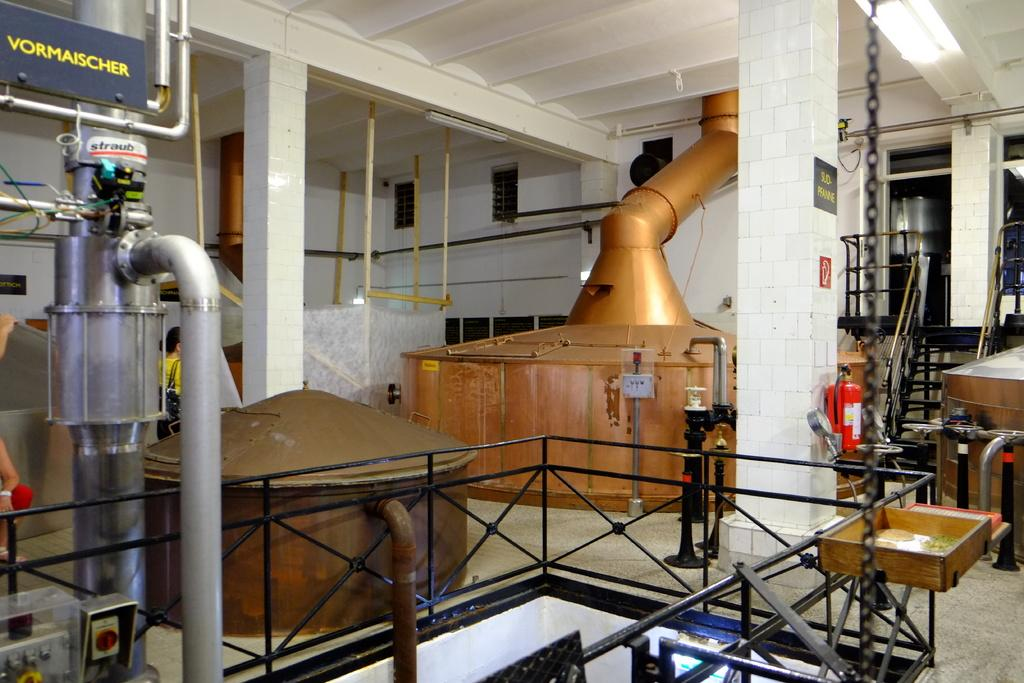What type of space is depicted in the image? The image is an inside view of a room. What can be found in the room? There are machines, pipes, boards, a wall, stairs, and a fire extinguisher in the room. What is the floor made of? The floor is not specified in the facts, so we cannot determine its material. What is visible at the top of the image? The top of the image shows a roof. What type of produce is being sorted on the boards in the image? There is no produce or sorting activity present in the image; it features machines, pipes, boards, a wall, stairs, and a fire extinguisher in a room. Is there a sink visible in the image? There is no sink mentioned or visible in the image. 